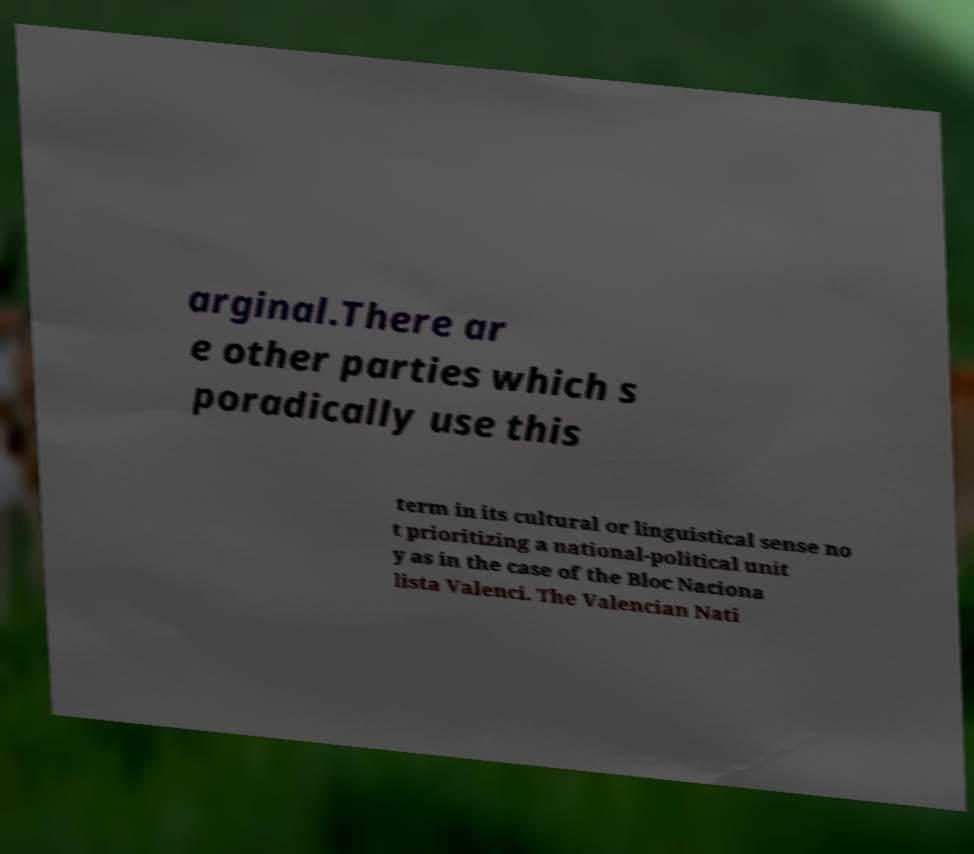There's text embedded in this image that I need extracted. Can you transcribe it verbatim? arginal.There ar e other parties which s poradically use this term in its cultural or linguistical sense no t prioritizing a national-political unit y as in the case of the Bloc Naciona lista Valenci. The Valencian Nati 